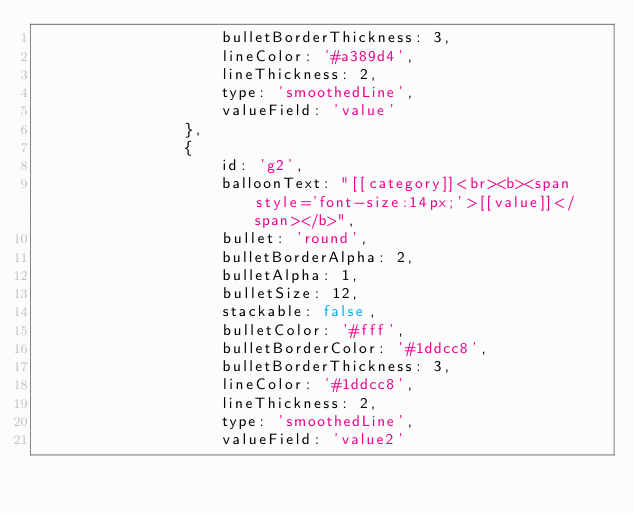Convert code to text. <code><loc_0><loc_0><loc_500><loc_500><_JavaScript_>                    bulletBorderThickness: 3,
                    lineColor: '#a389d4',
                    lineThickness: 2,
                    type: 'smoothedLine',
                    valueField: 'value'
                },
                {
                    id: 'g2',
                    balloonText: "[[category]]<br><b><span style='font-size:14px;'>[[value]]</span></b>",
                    bullet: 'round',
                    bulletBorderAlpha: 2,
                    bulletAlpha: 1,
                    bulletSize: 12,
                    stackable: false,
                    bulletColor: '#fff',
                    bulletBorderColor: '#1ddcc8',
                    bulletBorderThickness: 3,
                    lineColor: '#1ddcc8',
                    lineThickness: 2,
                    type: 'smoothedLine',
                    valueField: 'value2'</code> 